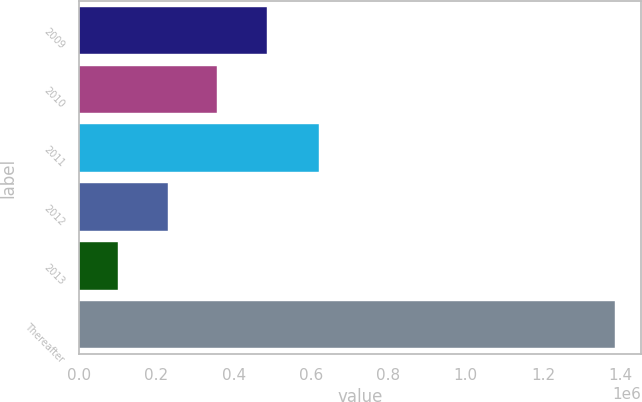Convert chart. <chart><loc_0><loc_0><loc_500><loc_500><bar_chart><fcel>2009<fcel>2010<fcel>2011<fcel>2012<fcel>2013<fcel>Thereafter<nl><fcel>485792<fcel>357340<fcel>620808<fcel>228888<fcel>100436<fcel>1.38496e+06<nl></chart> 